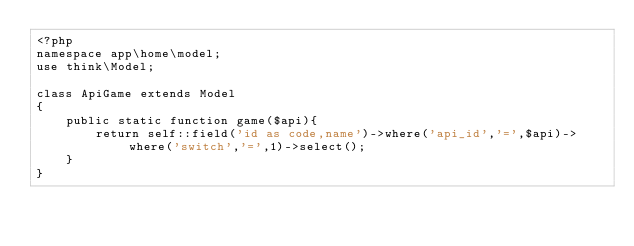Convert code to text. <code><loc_0><loc_0><loc_500><loc_500><_PHP_><?php
namespace app\home\model;
use think\Model;

class ApiGame extends Model
{
    public static function game($api){
        return self::field('id as code,name')->where('api_id','=',$api)->where('switch','=',1)->select();
    }
}
</code> 